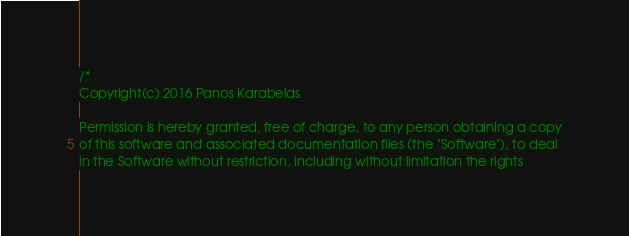Convert code to text. <code><loc_0><loc_0><loc_500><loc_500><_C++_>/*
Copyright(c) 2016 Panos Karabelas

Permission is hereby granted, free of charge, to any person obtaining a copy
of this software and associated documentation files (the "Software"), to deal
in the Software without restriction, including without limitation the rights</code> 